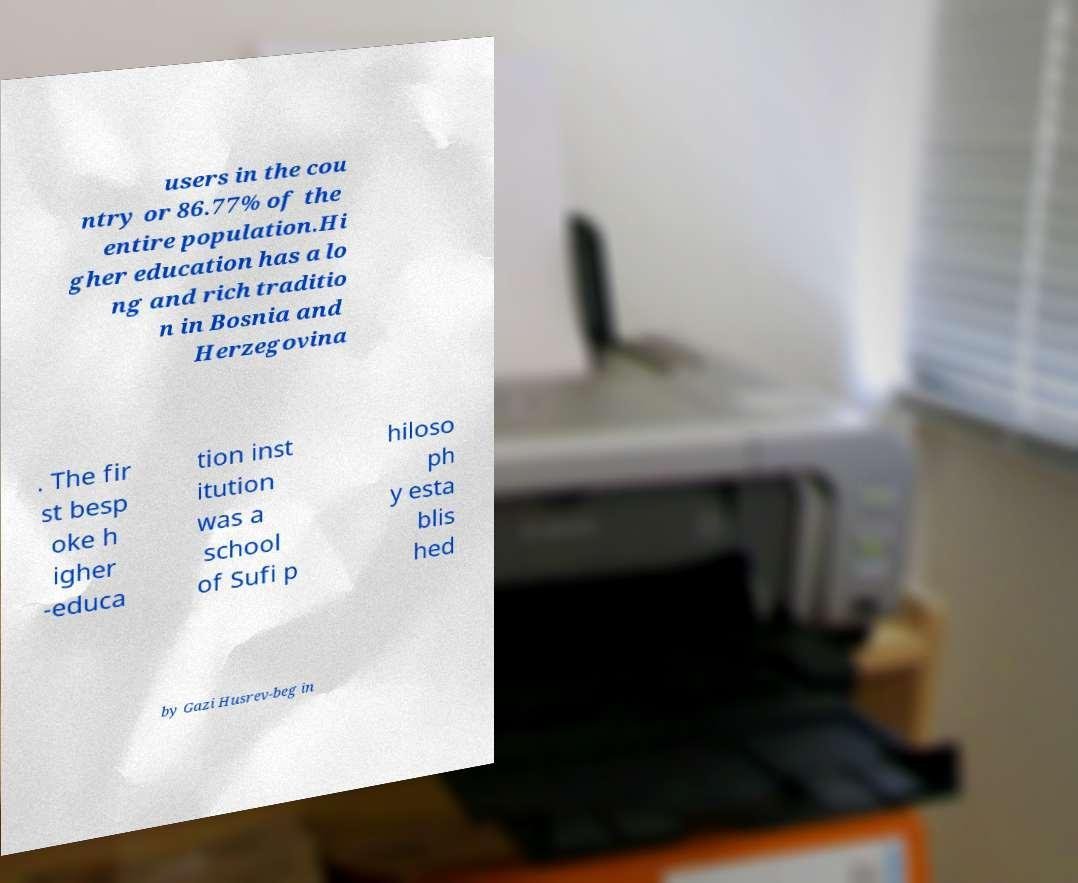Could you extract and type out the text from this image? users in the cou ntry or 86.77% of the entire population.Hi gher education has a lo ng and rich traditio n in Bosnia and Herzegovina . The fir st besp oke h igher -educa tion inst itution was a school of Sufi p hiloso ph y esta blis hed by Gazi Husrev-beg in 